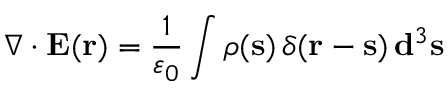Convert formula to latex. <formula><loc_0><loc_0><loc_500><loc_500>\nabla \cdot E ( r ) = { \frac { 1 } { \varepsilon _ { 0 } } } \int \rho ( s ) \, \delta ( r - s ) \, d ^ { 3 } s</formula> 